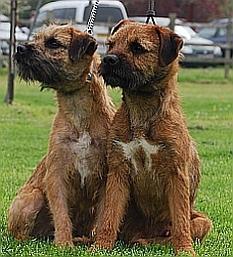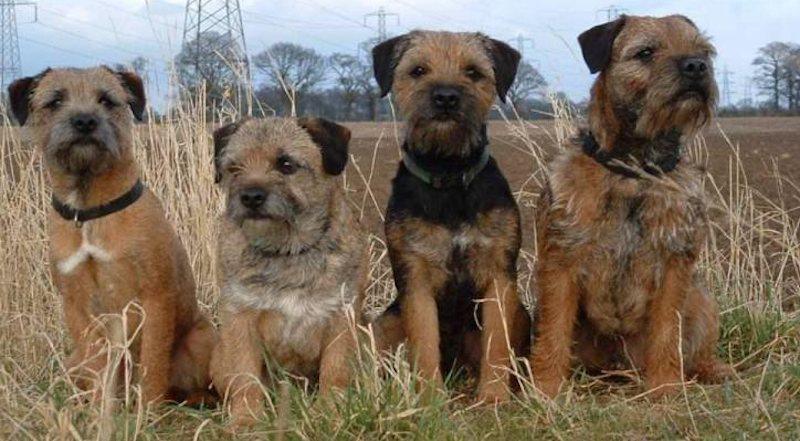The first image is the image on the left, the second image is the image on the right. For the images displayed, is the sentence "At least one dog in the left image is looking towards the left." factually correct? Answer yes or no. Yes. The first image is the image on the left, the second image is the image on the right. Given the left and right images, does the statement "A single dog is standing on all fours in the image on the left." hold true? Answer yes or no. No. The first image is the image on the left, the second image is the image on the right. Analyze the images presented: Is the assertion "There are no more than four dogs" valid? Answer yes or no. No. 